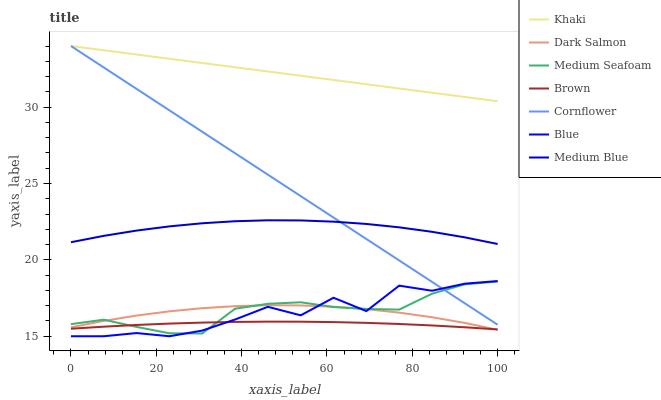Does Brown have the minimum area under the curve?
Answer yes or no. Yes. Does Khaki have the maximum area under the curve?
Answer yes or no. Yes. Does Cornflower have the minimum area under the curve?
Answer yes or no. No. Does Cornflower have the maximum area under the curve?
Answer yes or no. No. Is Cornflower the smoothest?
Answer yes or no. Yes. Is Blue the roughest?
Answer yes or no. Yes. Is Khaki the smoothest?
Answer yes or no. No. Is Khaki the roughest?
Answer yes or no. No. Does Blue have the lowest value?
Answer yes or no. Yes. Does Cornflower have the lowest value?
Answer yes or no. No. Does Khaki have the highest value?
Answer yes or no. Yes. Does Brown have the highest value?
Answer yes or no. No. Is Blue less than Medium Blue?
Answer yes or no. Yes. Is Khaki greater than Medium Seafoam?
Answer yes or no. Yes. Does Brown intersect Dark Salmon?
Answer yes or no. Yes. Is Brown less than Dark Salmon?
Answer yes or no. No. Is Brown greater than Dark Salmon?
Answer yes or no. No. Does Blue intersect Medium Blue?
Answer yes or no. No. 